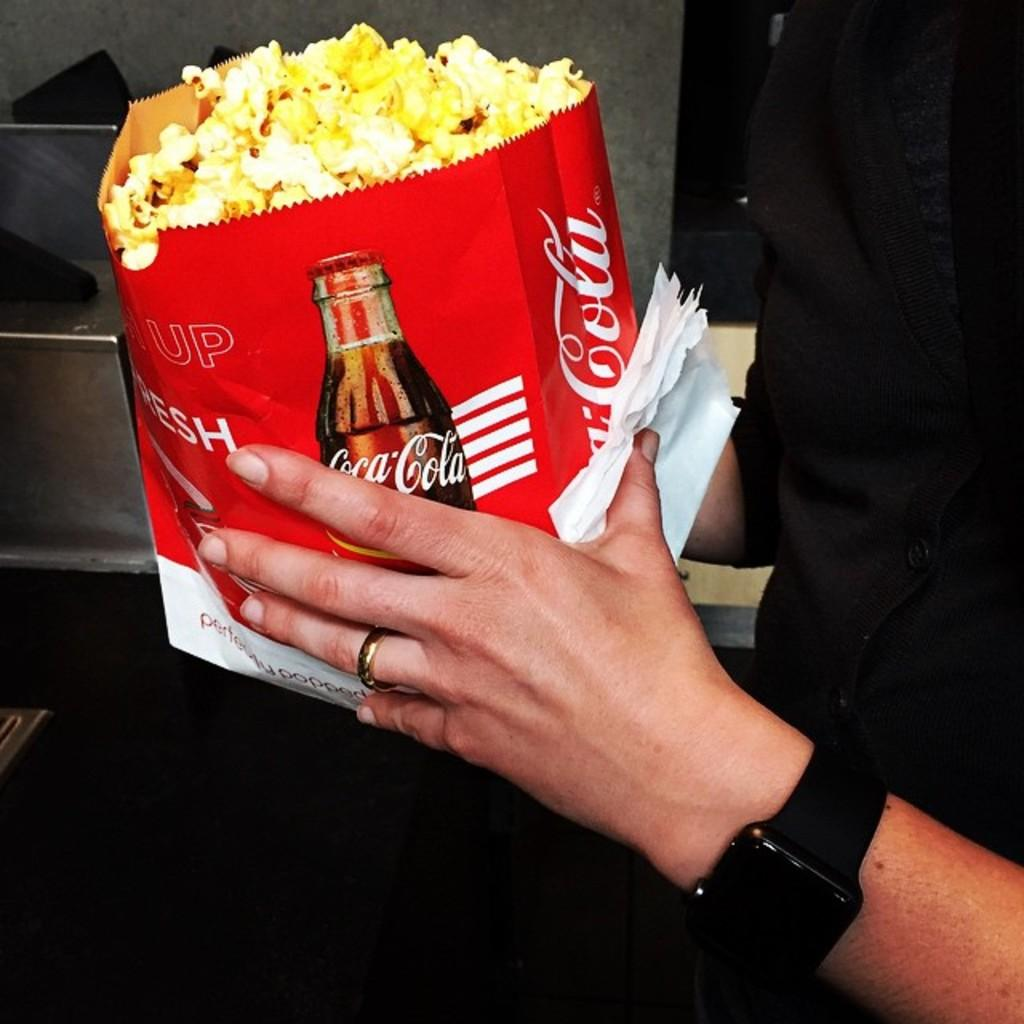Provide a one-sentence caption for the provided image. A red and white bag of popcorn with a Coca Cola logo and bottle. 